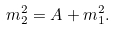Convert formula to latex. <formula><loc_0><loc_0><loc_500><loc_500>m _ { 2 } ^ { 2 } = A + m _ { 1 } ^ { 2 } .</formula> 